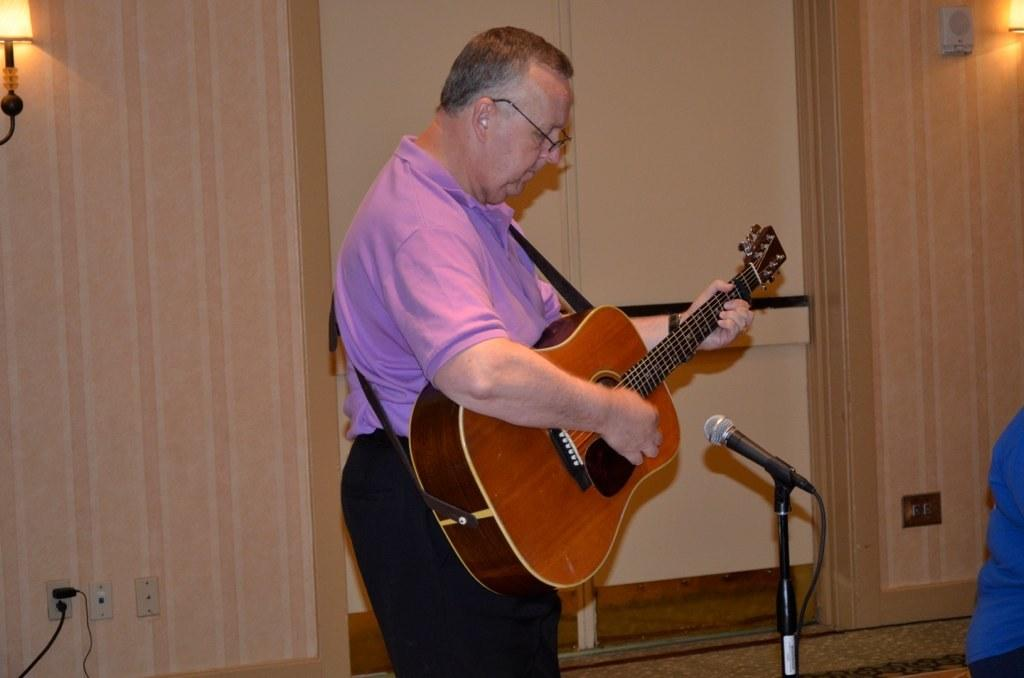What is the man in the image doing? The man is playing a guitar. What is the man's position in the image? The man is standing. What object is near the man in the image? The man is near a microphone. What can be seen in the background of the image? There is a lamp and a wall in the background of the image. What type of joke is the man telling near the can in the image? There is no joke or can present in the image; the man is playing a guitar near a microphone. Is there a cake visible in the image? No, there is no cake present in the image. 